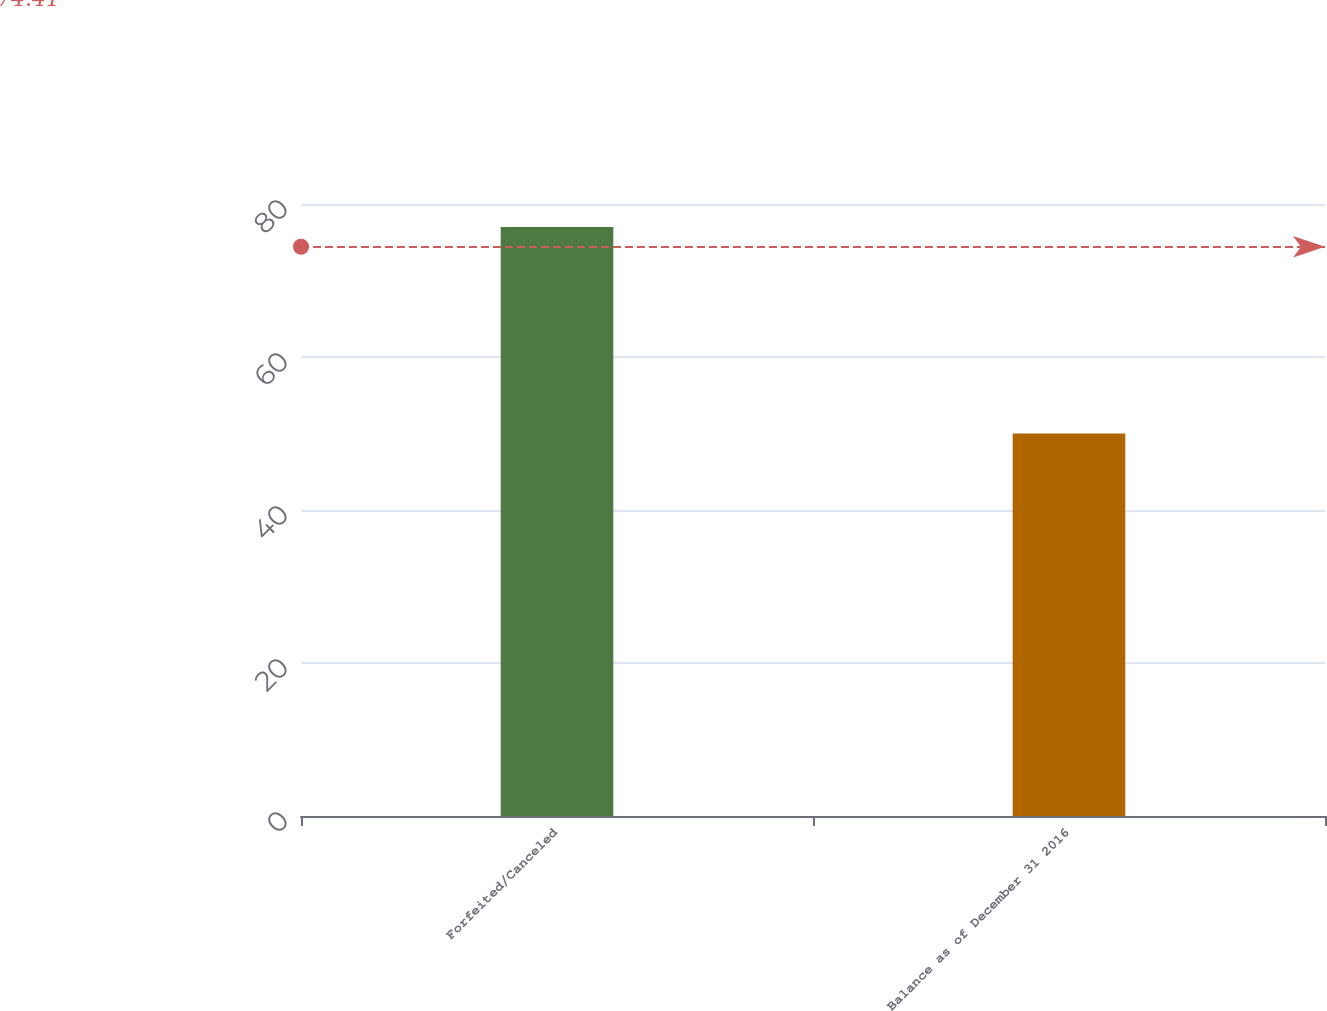Convert chart. <chart><loc_0><loc_0><loc_500><loc_500><bar_chart><fcel>Forfeited/Canceled<fcel>Balance as of December 31 2016<nl><fcel>77<fcel>50<nl></chart> 